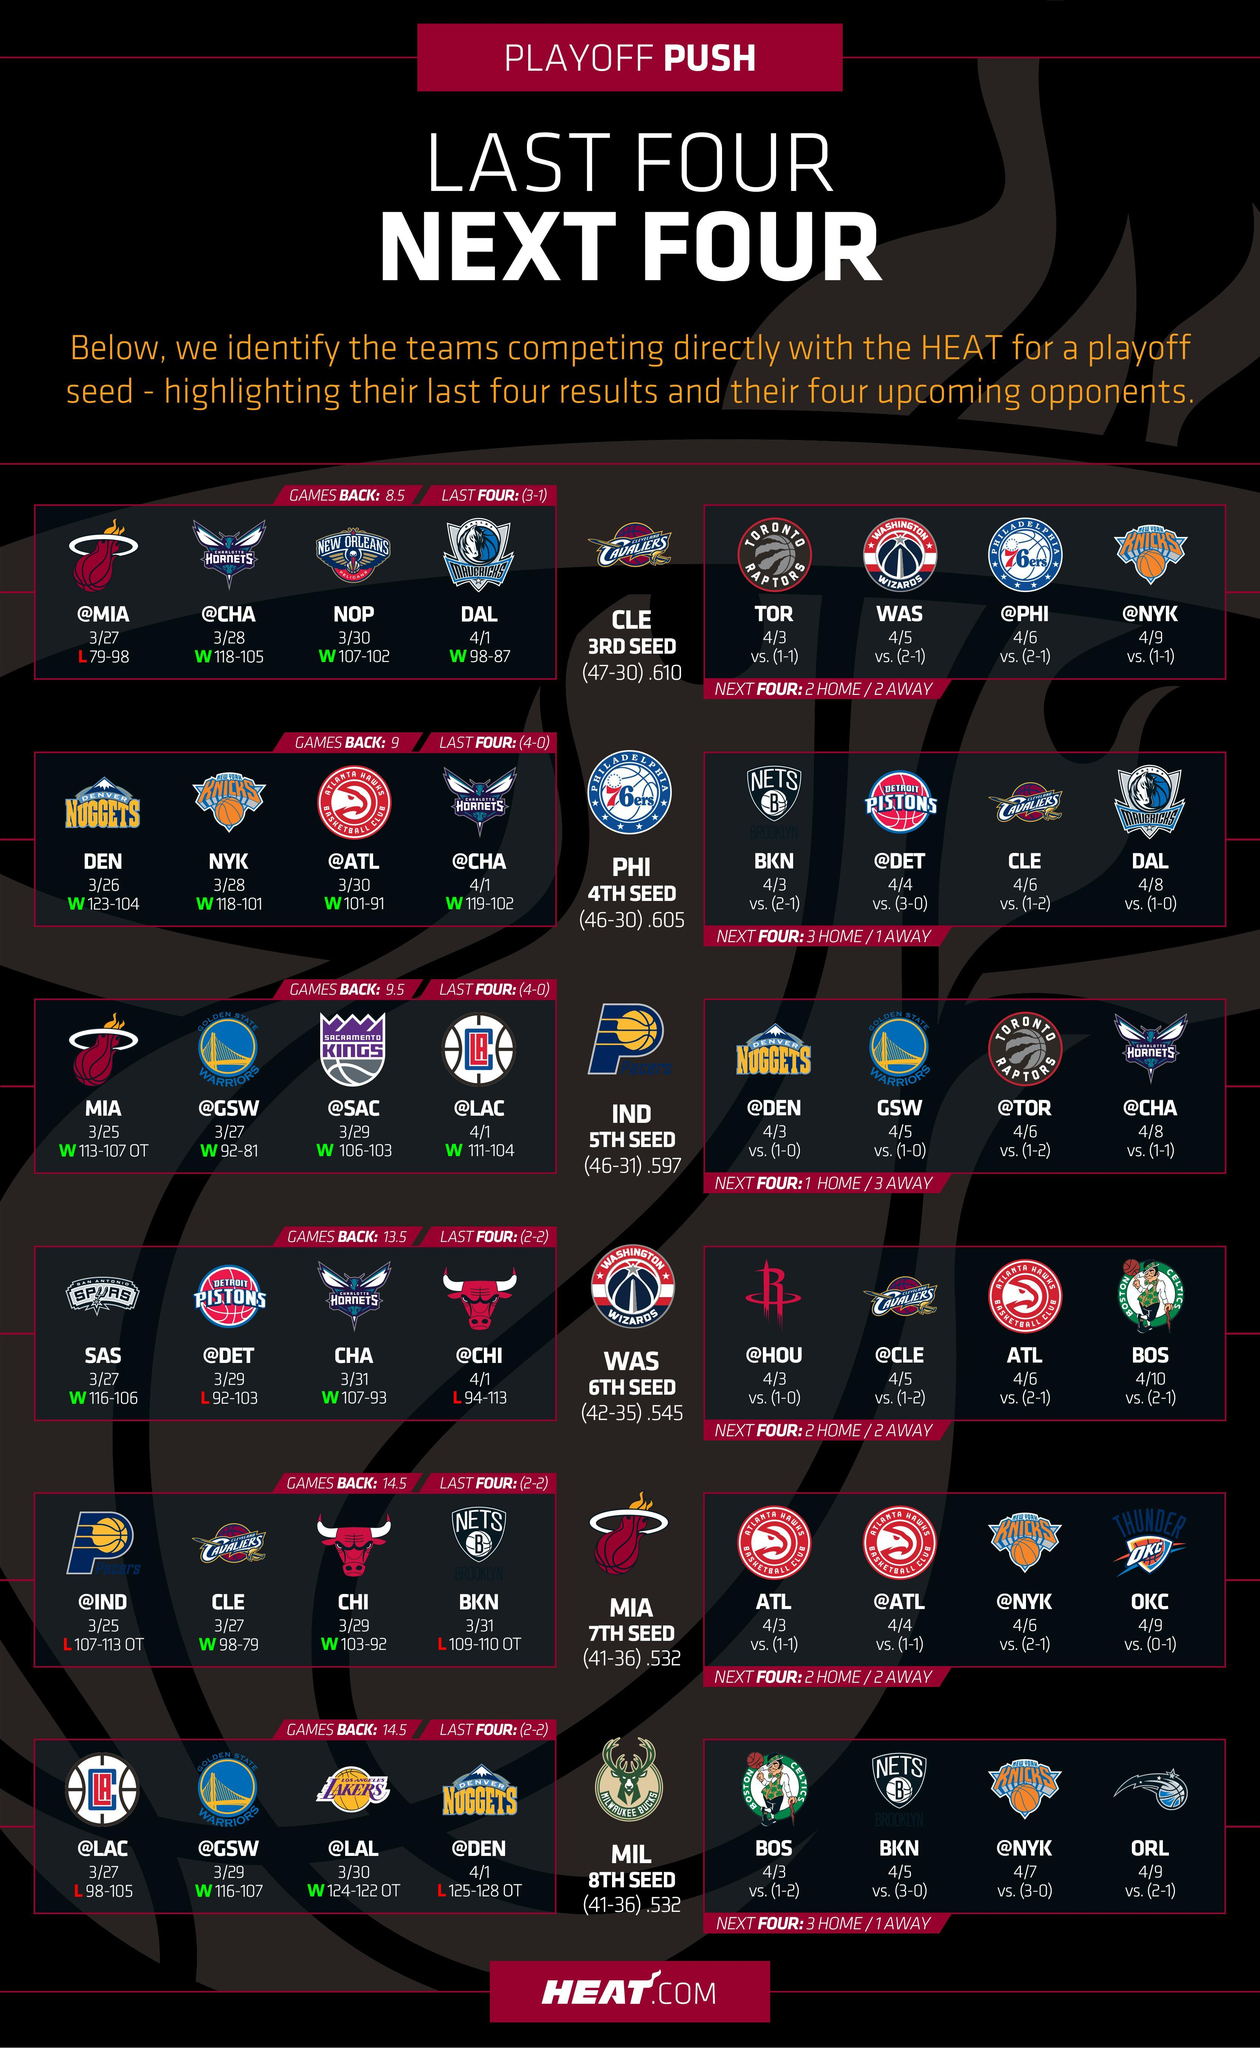How many rows are in this infographic?
Answer the question with a short phrase. 6 